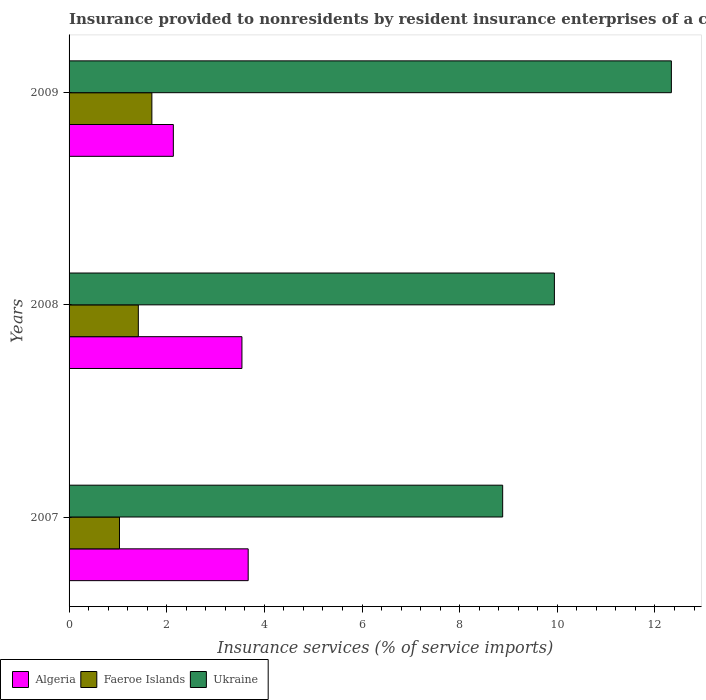Are the number of bars on each tick of the Y-axis equal?
Provide a short and direct response. Yes. How many bars are there on the 2nd tick from the top?
Offer a terse response. 3. How many bars are there on the 1st tick from the bottom?
Keep it short and to the point. 3. In how many cases, is the number of bars for a given year not equal to the number of legend labels?
Give a very brief answer. 0. What is the insurance provided to nonresidents in Algeria in 2008?
Your answer should be compact. 3.54. Across all years, what is the maximum insurance provided to nonresidents in Faeroe Islands?
Your answer should be compact. 1.7. Across all years, what is the minimum insurance provided to nonresidents in Faeroe Islands?
Give a very brief answer. 1.03. In which year was the insurance provided to nonresidents in Algeria maximum?
Provide a succinct answer. 2007. In which year was the insurance provided to nonresidents in Faeroe Islands minimum?
Offer a terse response. 2007. What is the total insurance provided to nonresidents in Ukraine in the graph?
Offer a very short reply. 31.16. What is the difference between the insurance provided to nonresidents in Faeroe Islands in 2007 and that in 2009?
Provide a short and direct response. -0.66. What is the difference between the insurance provided to nonresidents in Ukraine in 2009 and the insurance provided to nonresidents in Algeria in 2007?
Your answer should be compact. 8.67. What is the average insurance provided to nonresidents in Faeroe Islands per year?
Your answer should be very brief. 1.38. In the year 2008, what is the difference between the insurance provided to nonresidents in Ukraine and insurance provided to nonresidents in Algeria?
Provide a succinct answer. 6.4. What is the ratio of the insurance provided to nonresidents in Algeria in 2008 to that in 2009?
Ensure brevity in your answer.  1.66. Is the insurance provided to nonresidents in Ukraine in 2007 less than that in 2009?
Offer a very short reply. Yes. What is the difference between the highest and the second highest insurance provided to nonresidents in Ukraine?
Your response must be concise. 2.4. What is the difference between the highest and the lowest insurance provided to nonresidents in Algeria?
Keep it short and to the point. 1.53. In how many years, is the insurance provided to nonresidents in Ukraine greater than the average insurance provided to nonresidents in Ukraine taken over all years?
Your response must be concise. 1. What does the 3rd bar from the top in 2008 represents?
Your answer should be compact. Algeria. What does the 2nd bar from the bottom in 2008 represents?
Offer a very short reply. Faeroe Islands. Is it the case that in every year, the sum of the insurance provided to nonresidents in Algeria and insurance provided to nonresidents in Ukraine is greater than the insurance provided to nonresidents in Faeroe Islands?
Provide a short and direct response. Yes. How many bars are there?
Your answer should be compact. 9. Are all the bars in the graph horizontal?
Your answer should be compact. Yes. What is the difference between two consecutive major ticks on the X-axis?
Give a very brief answer. 2. Are the values on the major ticks of X-axis written in scientific E-notation?
Your answer should be compact. No. Where does the legend appear in the graph?
Offer a terse response. Bottom left. How many legend labels are there?
Offer a very short reply. 3. How are the legend labels stacked?
Offer a very short reply. Horizontal. What is the title of the graph?
Your response must be concise. Insurance provided to nonresidents by resident insurance enterprises of a country. Does "Hong Kong" appear as one of the legend labels in the graph?
Provide a short and direct response. No. What is the label or title of the X-axis?
Your answer should be very brief. Insurance services (% of service imports). What is the label or title of the Y-axis?
Offer a very short reply. Years. What is the Insurance services (% of service imports) of Algeria in 2007?
Provide a short and direct response. 3.67. What is the Insurance services (% of service imports) in Faeroe Islands in 2007?
Give a very brief answer. 1.03. What is the Insurance services (% of service imports) in Ukraine in 2007?
Your response must be concise. 8.88. What is the Insurance services (% of service imports) in Algeria in 2008?
Offer a terse response. 3.54. What is the Insurance services (% of service imports) in Faeroe Islands in 2008?
Give a very brief answer. 1.42. What is the Insurance services (% of service imports) of Ukraine in 2008?
Offer a terse response. 9.94. What is the Insurance services (% of service imports) in Algeria in 2009?
Keep it short and to the point. 2.14. What is the Insurance services (% of service imports) of Faeroe Islands in 2009?
Offer a terse response. 1.7. What is the Insurance services (% of service imports) in Ukraine in 2009?
Offer a terse response. 12.34. Across all years, what is the maximum Insurance services (% of service imports) in Algeria?
Ensure brevity in your answer.  3.67. Across all years, what is the maximum Insurance services (% of service imports) of Faeroe Islands?
Give a very brief answer. 1.7. Across all years, what is the maximum Insurance services (% of service imports) of Ukraine?
Provide a succinct answer. 12.34. Across all years, what is the minimum Insurance services (% of service imports) of Algeria?
Your response must be concise. 2.14. Across all years, what is the minimum Insurance services (% of service imports) in Faeroe Islands?
Your response must be concise. 1.03. Across all years, what is the minimum Insurance services (% of service imports) in Ukraine?
Your answer should be very brief. 8.88. What is the total Insurance services (% of service imports) in Algeria in the graph?
Ensure brevity in your answer.  9.34. What is the total Insurance services (% of service imports) in Faeroe Islands in the graph?
Your response must be concise. 4.15. What is the total Insurance services (% of service imports) of Ukraine in the graph?
Offer a terse response. 31.16. What is the difference between the Insurance services (% of service imports) in Algeria in 2007 and that in 2008?
Your response must be concise. 0.13. What is the difference between the Insurance services (% of service imports) of Faeroe Islands in 2007 and that in 2008?
Provide a succinct answer. -0.39. What is the difference between the Insurance services (% of service imports) of Ukraine in 2007 and that in 2008?
Keep it short and to the point. -1.06. What is the difference between the Insurance services (% of service imports) in Algeria in 2007 and that in 2009?
Give a very brief answer. 1.53. What is the difference between the Insurance services (% of service imports) in Faeroe Islands in 2007 and that in 2009?
Give a very brief answer. -0.66. What is the difference between the Insurance services (% of service imports) in Ukraine in 2007 and that in 2009?
Your answer should be very brief. -3.46. What is the difference between the Insurance services (% of service imports) of Algeria in 2008 and that in 2009?
Your response must be concise. 1.41. What is the difference between the Insurance services (% of service imports) of Faeroe Islands in 2008 and that in 2009?
Offer a terse response. -0.28. What is the difference between the Insurance services (% of service imports) of Ukraine in 2008 and that in 2009?
Your response must be concise. -2.4. What is the difference between the Insurance services (% of service imports) of Algeria in 2007 and the Insurance services (% of service imports) of Faeroe Islands in 2008?
Give a very brief answer. 2.25. What is the difference between the Insurance services (% of service imports) of Algeria in 2007 and the Insurance services (% of service imports) of Ukraine in 2008?
Provide a short and direct response. -6.27. What is the difference between the Insurance services (% of service imports) of Faeroe Islands in 2007 and the Insurance services (% of service imports) of Ukraine in 2008?
Provide a succinct answer. -8.91. What is the difference between the Insurance services (% of service imports) of Algeria in 2007 and the Insurance services (% of service imports) of Faeroe Islands in 2009?
Your answer should be compact. 1.97. What is the difference between the Insurance services (% of service imports) in Algeria in 2007 and the Insurance services (% of service imports) in Ukraine in 2009?
Offer a very short reply. -8.67. What is the difference between the Insurance services (% of service imports) of Faeroe Islands in 2007 and the Insurance services (% of service imports) of Ukraine in 2009?
Make the answer very short. -11.3. What is the difference between the Insurance services (% of service imports) in Algeria in 2008 and the Insurance services (% of service imports) in Faeroe Islands in 2009?
Offer a very short reply. 1.84. What is the difference between the Insurance services (% of service imports) in Algeria in 2008 and the Insurance services (% of service imports) in Ukraine in 2009?
Give a very brief answer. -8.8. What is the difference between the Insurance services (% of service imports) in Faeroe Islands in 2008 and the Insurance services (% of service imports) in Ukraine in 2009?
Ensure brevity in your answer.  -10.92. What is the average Insurance services (% of service imports) of Algeria per year?
Provide a short and direct response. 3.11. What is the average Insurance services (% of service imports) of Faeroe Islands per year?
Your answer should be compact. 1.38. What is the average Insurance services (% of service imports) in Ukraine per year?
Your response must be concise. 10.39. In the year 2007, what is the difference between the Insurance services (% of service imports) in Algeria and Insurance services (% of service imports) in Faeroe Islands?
Your answer should be very brief. 2.64. In the year 2007, what is the difference between the Insurance services (% of service imports) in Algeria and Insurance services (% of service imports) in Ukraine?
Your response must be concise. -5.21. In the year 2007, what is the difference between the Insurance services (% of service imports) of Faeroe Islands and Insurance services (% of service imports) of Ukraine?
Your answer should be compact. -7.85. In the year 2008, what is the difference between the Insurance services (% of service imports) of Algeria and Insurance services (% of service imports) of Faeroe Islands?
Your answer should be compact. 2.12. In the year 2008, what is the difference between the Insurance services (% of service imports) in Algeria and Insurance services (% of service imports) in Ukraine?
Your answer should be compact. -6.4. In the year 2008, what is the difference between the Insurance services (% of service imports) of Faeroe Islands and Insurance services (% of service imports) of Ukraine?
Offer a very short reply. -8.52. In the year 2009, what is the difference between the Insurance services (% of service imports) of Algeria and Insurance services (% of service imports) of Faeroe Islands?
Provide a short and direct response. 0.44. In the year 2009, what is the difference between the Insurance services (% of service imports) in Algeria and Insurance services (% of service imports) in Ukraine?
Offer a terse response. -10.2. In the year 2009, what is the difference between the Insurance services (% of service imports) in Faeroe Islands and Insurance services (% of service imports) in Ukraine?
Offer a terse response. -10.64. What is the ratio of the Insurance services (% of service imports) in Algeria in 2007 to that in 2008?
Make the answer very short. 1.04. What is the ratio of the Insurance services (% of service imports) of Faeroe Islands in 2007 to that in 2008?
Provide a short and direct response. 0.73. What is the ratio of the Insurance services (% of service imports) of Ukraine in 2007 to that in 2008?
Give a very brief answer. 0.89. What is the ratio of the Insurance services (% of service imports) in Algeria in 2007 to that in 2009?
Your answer should be compact. 1.72. What is the ratio of the Insurance services (% of service imports) of Faeroe Islands in 2007 to that in 2009?
Give a very brief answer. 0.61. What is the ratio of the Insurance services (% of service imports) of Ukraine in 2007 to that in 2009?
Offer a very short reply. 0.72. What is the ratio of the Insurance services (% of service imports) of Algeria in 2008 to that in 2009?
Provide a short and direct response. 1.66. What is the ratio of the Insurance services (% of service imports) in Faeroe Islands in 2008 to that in 2009?
Give a very brief answer. 0.84. What is the ratio of the Insurance services (% of service imports) of Ukraine in 2008 to that in 2009?
Your answer should be very brief. 0.81. What is the difference between the highest and the second highest Insurance services (% of service imports) in Algeria?
Your answer should be very brief. 0.13. What is the difference between the highest and the second highest Insurance services (% of service imports) in Faeroe Islands?
Your answer should be very brief. 0.28. What is the difference between the highest and the second highest Insurance services (% of service imports) of Ukraine?
Keep it short and to the point. 2.4. What is the difference between the highest and the lowest Insurance services (% of service imports) in Algeria?
Provide a succinct answer. 1.53. What is the difference between the highest and the lowest Insurance services (% of service imports) of Faeroe Islands?
Ensure brevity in your answer.  0.66. What is the difference between the highest and the lowest Insurance services (% of service imports) of Ukraine?
Offer a very short reply. 3.46. 